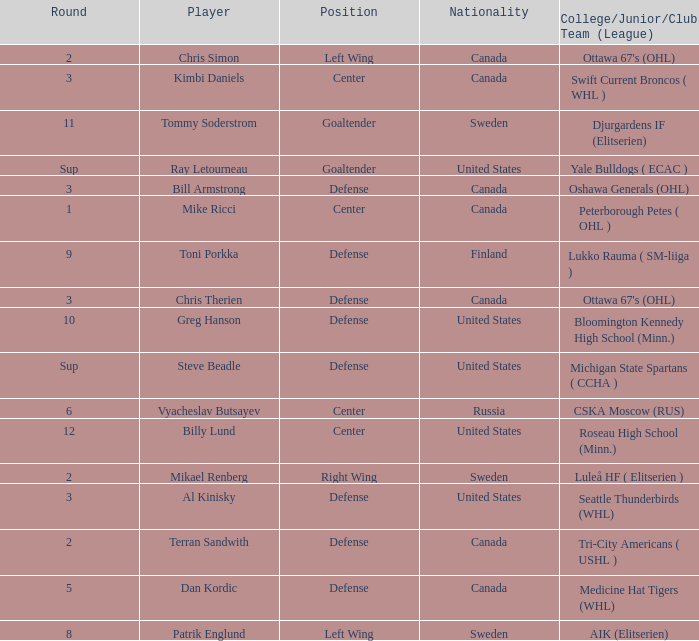What is the school that hosts mikael renberg Luleå HF ( Elitserien ). 